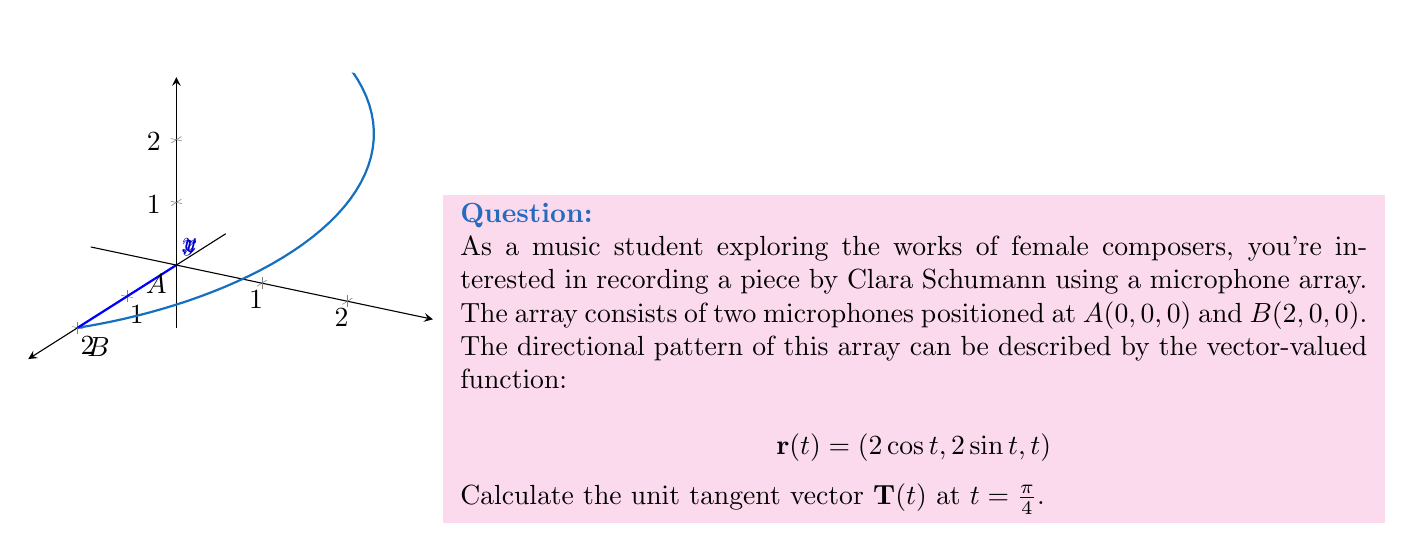Can you answer this question? To find the unit tangent vector $\mathbf{T}(t)$, we need to follow these steps:

1) First, calculate $\mathbf{r}'(t)$:
   $$\mathbf{r}'(t) = (-2\sin t, 2\cos t, 1)$$

2) Evaluate $\mathbf{r}'(t)$ at $t = \frac{\pi}{4}$:
   $$\mathbf{r}'(\frac{\pi}{4}) = (-2\sin \frac{\pi}{4}, 2\cos \frac{\pi}{4}, 1)$$
   $$= (-\sqrt{2}, \sqrt{2}, 1)$$

3) Calculate the magnitude of $\mathbf{r}'(\frac{\pi}{4})$:
   $$\|\mathbf{r}'(\frac{\pi}{4})\| = \sqrt{(-\sqrt{2})^2 + (\sqrt{2})^2 + 1^2}$$
   $$= \sqrt{2 + 2 + 1} = \sqrt{5}$$

4) The unit tangent vector $\mathbf{T}(t)$ is given by:
   $$\mathbf{T}(t) = \frac{\mathbf{r}'(t)}{\|\mathbf{r}'(t)\|}$$

5) Therefore, $\mathbf{T}(\frac{\pi}{4})$ is:
   $$\mathbf{T}(\frac{\pi}{4}) = \frac{(-\sqrt{2}, \sqrt{2}, 1)}{\sqrt{5}}$$
   $$= (-\frac{\sqrt{2}}{\sqrt{5}}, \frac{\sqrt{2}}{\sqrt{5}}, \frac{1}{\sqrt{5}})$$
Answer: $(-\frac{\sqrt{2}}{\sqrt{5}}, \frac{\sqrt{2}}{\sqrt{5}}, \frac{1}{\sqrt{5}})$ 